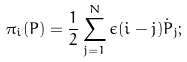<formula> <loc_0><loc_0><loc_500><loc_500>\pi _ { i } ( P ) = { \frac { 1 } { 2 } } \sum _ { j = 1 } ^ { N } \epsilon ( i - j ) { \dot { P } } _ { j } ;</formula> 